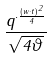<formula> <loc_0><loc_0><loc_500><loc_500>\frac { q ^ { \cdot \frac { ( w \cdot t ) ^ { 2 } } { 4 } } } { \sqrt { 4 \vartheta } }</formula> 